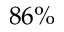Convert formula to latex. <formula><loc_0><loc_0><loc_500><loc_500>8 6 \%</formula> 